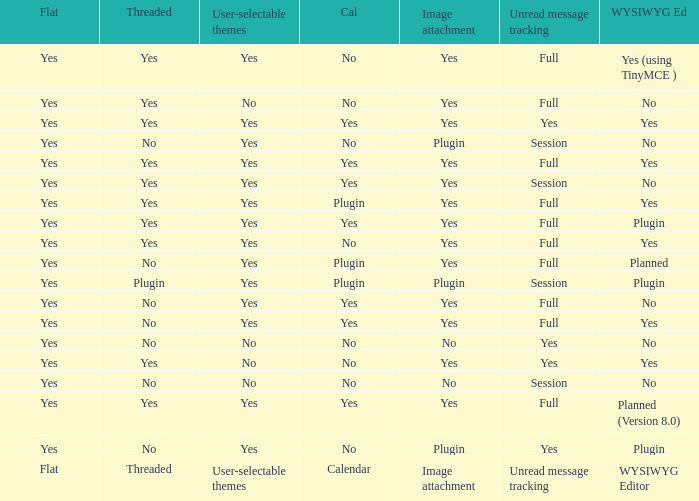Which WYSIWYG Editor has a User-selectable themes of yes, and an Unread message tracking of session, and an Image attachment of plugin? No, Plugin. 